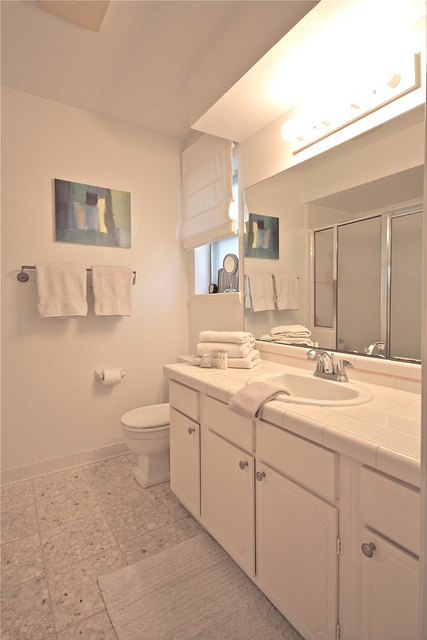What might be the advantages of the bathroom layout? The bathroom layout is remarkably efficient, promoting ease of movement with its generous open floor space. The long white sink countertop is a significant advantage, offering extensive room for multiple users to place their toiletries and personal items, which is ideal for busy mornings. The positioning of the toilet beside the sink maintains a clear separation from the bathing area, enhancing privacy and functionality. Storage is also considered with ample cabinetry beneath the sink, hiding away cleaning products and additional toiletries, thus contributing to a tidy environment. The large mirror increases the sense of openness and reflects light throughout the space, making it appear even larger. Decorative elements, such as the wall-mounted artwork, add a touch of personality, transforming a purely functional space into an inviting one. The monochromatic white theme enhances the clean, calm vibe that most homeowners seek in a bathroom sanctuary. 